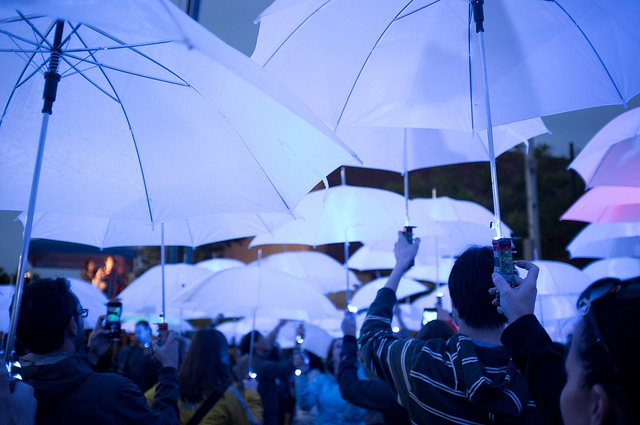Describe the objects in this image and their specific colors. I can see umbrella in blue, lightblue, and lavender tones, umbrella in blue, lightblue, and lavender tones, people in blue, black, and navy tones, people in blue, black, navy, and darkblue tones, and people in blue, black, navy, and darkblue tones in this image. 